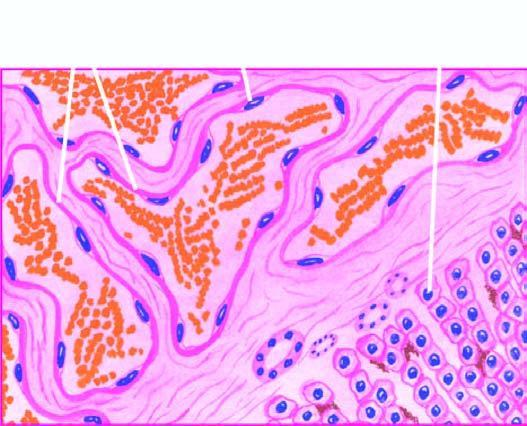what are large, dilated, many containing blood, and are lined by flattened endothelial cells?
Answer the question using a single word or phrase. Vascular spaces 